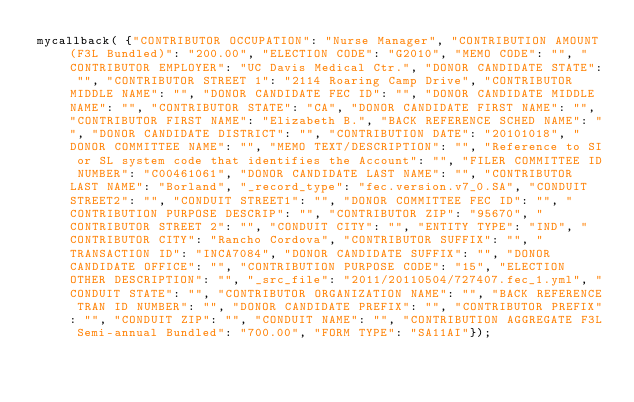Convert code to text. <code><loc_0><loc_0><loc_500><loc_500><_JavaScript_>mycallback( {"CONTRIBUTOR OCCUPATION": "Nurse Manager", "CONTRIBUTION AMOUNT (F3L Bundled)": "200.00", "ELECTION CODE": "G2010", "MEMO CODE": "", "CONTRIBUTOR EMPLOYER": "UC Davis Medical Ctr.", "DONOR CANDIDATE STATE": "", "CONTRIBUTOR STREET 1": "2114 Roaring Camp Drive", "CONTRIBUTOR MIDDLE NAME": "", "DONOR CANDIDATE FEC ID": "", "DONOR CANDIDATE MIDDLE NAME": "", "CONTRIBUTOR STATE": "CA", "DONOR CANDIDATE FIRST NAME": "", "CONTRIBUTOR FIRST NAME": "Elizabeth B.", "BACK REFERENCE SCHED NAME": "", "DONOR CANDIDATE DISTRICT": "", "CONTRIBUTION DATE": "20101018", "DONOR COMMITTEE NAME": "", "MEMO TEXT/DESCRIPTION": "", "Reference to SI or SL system code that identifies the Account": "", "FILER COMMITTEE ID NUMBER": "C00461061", "DONOR CANDIDATE LAST NAME": "", "CONTRIBUTOR LAST NAME": "Borland", "_record_type": "fec.version.v7_0.SA", "CONDUIT STREET2": "", "CONDUIT STREET1": "", "DONOR COMMITTEE FEC ID": "", "CONTRIBUTION PURPOSE DESCRIP": "", "CONTRIBUTOR ZIP": "95670", "CONTRIBUTOR STREET 2": "", "CONDUIT CITY": "", "ENTITY TYPE": "IND", "CONTRIBUTOR CITY": "Rancho Cordova", "CONTRIBUTOR SUFFIX": "", "TRANSACTION ID": "INCA7084", "DONOR CANDIDATE SUFFIX": "", "DONOR CANDIDATE OFFICE": "", "CONTRIBUTION PURPOSE CODE": "15", "ELECTION OTHER DESCRIPTION": "", "_src_file": "2011/20110504/727407.fec_1.yml", "CONDUIT STATE": "", "CONTRIBUTOR ORGANIZATION NAME": "", "BACK REFERENCE TRAN ID NUMBER": "", "DONOR CANDIDATE PREFIX": "", "CONTRIBUTOR PREFIX": "", "CONDUIT ZIP": "", "CONDUIT NAME": "", "CONTRIBUTION AGGREGATE F3L Semi-annual Bundled": "700.00", "FORM TYPE": "SA11AI"});
</code> 